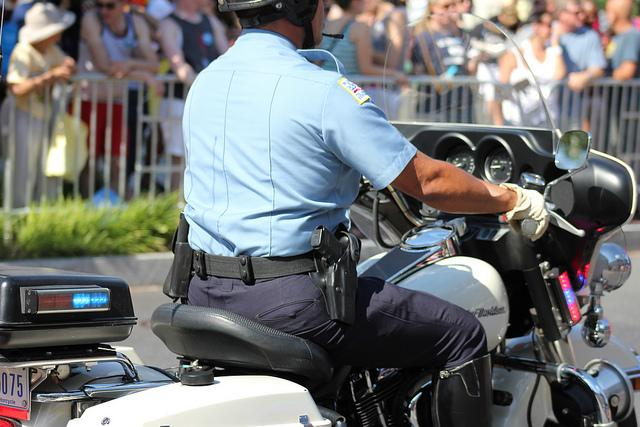What part of the cops uniform has the most similar theme to the motorcycle?

Choices:
A) shirt
B) gloves
C) belt
D) boots gloves 